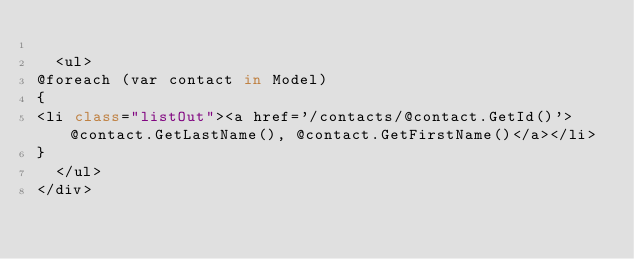Convert code to text. <code><loc_0><loc_0><loc_500><loc_500><_C#_>
  <ul>
@foreach (var contact in Model)
{
<li class="listOut"><a href='/contacts/@contact.GetId()'>@contact.GetLastName(), @contact.GetFirstName()</a></li>
}
  </ul>
</div>
</code> 